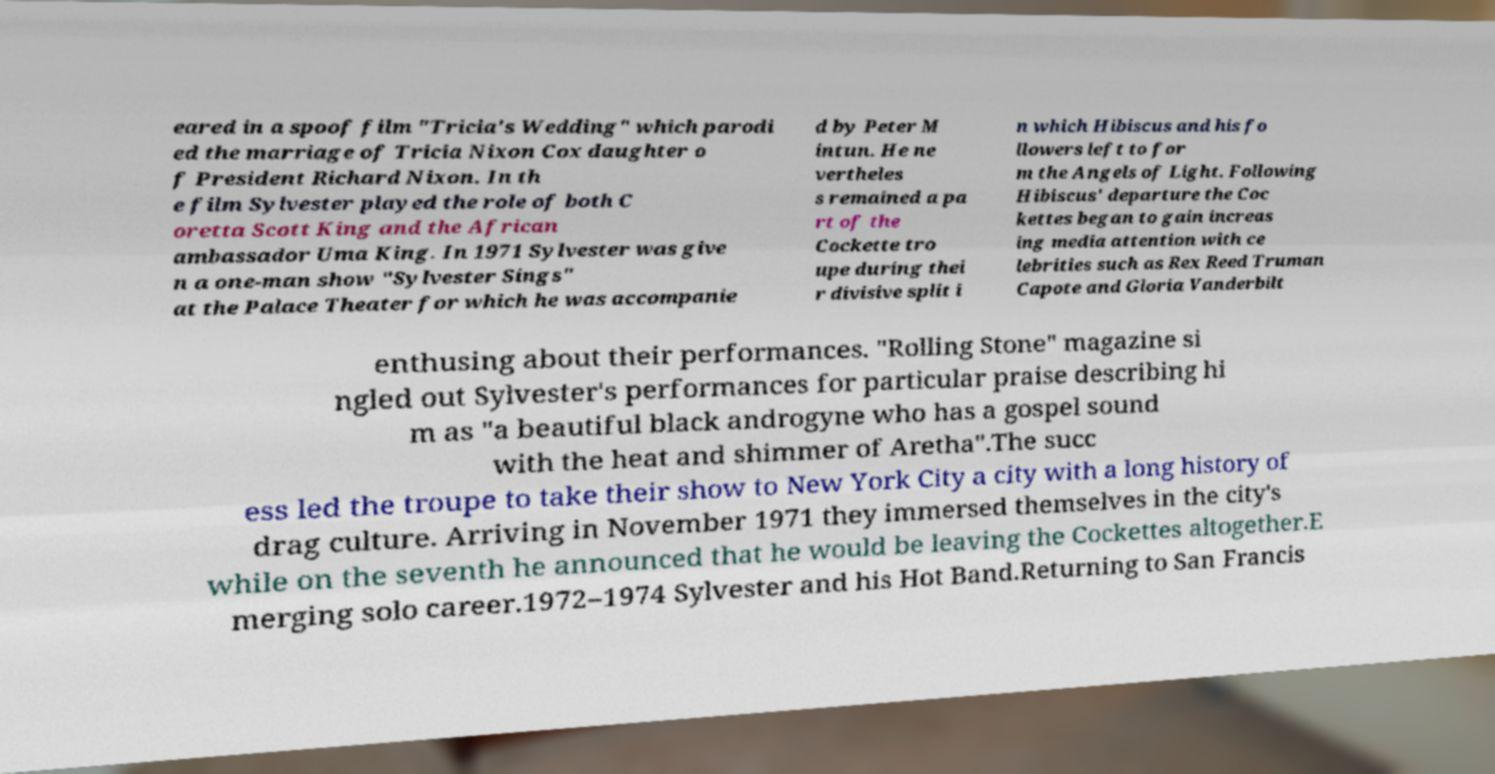I need the written content from this picture converted into text. Can you do that? eared in a spoof film "Tricia's Wedding" which parodi ed the marriage of Tricia Nixon Cox daughter o f President Richard Nixon. In th e film Sylvester played the role of both C oretta Scott King and the African ambassador Uma King. In 1971 Sylvester was give n a one-man show "Sylvester Sings" at the Palace Theater for which he was accompanie d by Peter M intun. He ne vertheles s remained a pa rt of the Cockette tro upe during thei r divisive split i n which Hibiscus and his fo llowers left to for m the Angels of Light. Following Hibiscus' departure the Coc kettes began to gain increas ing media attention with ce lebrities such as Rex Reed Truman Capote and Gloria Vanderbilt enthusing about their performances. "Rolling Stone" magazine si ngled out Sylvester's performances for particular praise describing hi m as "a beautiful black androgyne who has a gospel sound with the heat and shimmer of Aretha".The succ ess led the troupe to take their show to New York City a city with a long history of drag culture. Arriving in November 1971 they immersed themselves in the city's while on the seventh he announced that he would be leaving the Cockettes altogether.E merging solo career.1972–1974 Sylvester and his Hot Band.Returning to San Francis 